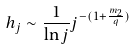<formula> <loc_0><loc_0><loc_500><loc_500>h _ { j } \sim \frac { 1 } { \ln j } j ^ { - ( 1 + \frac { m _ { 2 } } { q } ) }</formula> 